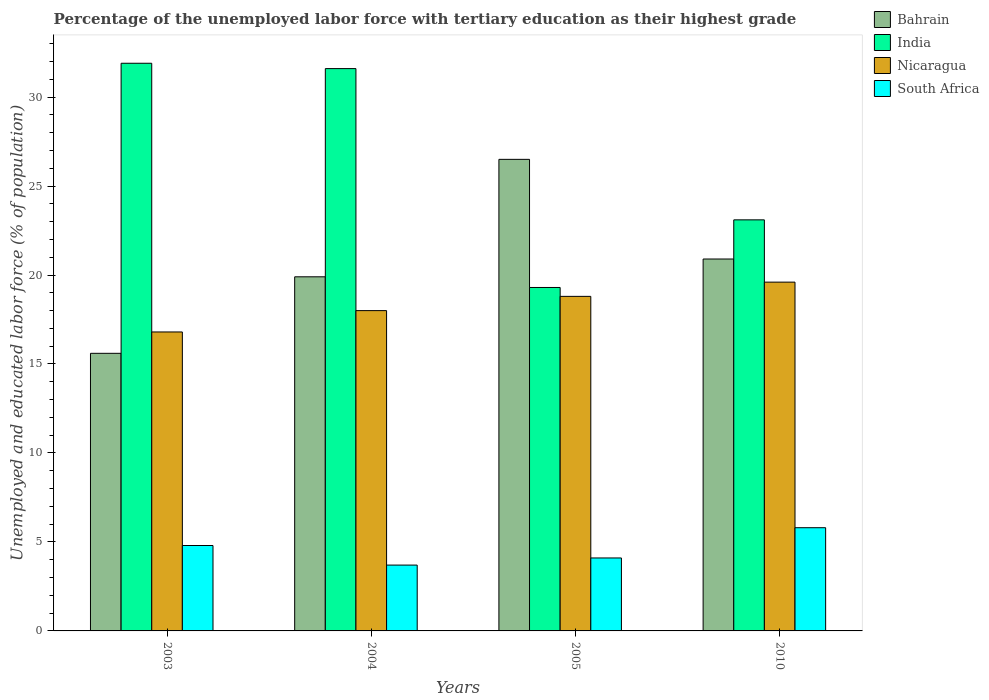Are the number of bars per tick equal to the number of legend labels?
Offer a very short reply. Yes. Are the number of bars on each tick of the X-axis equal?
Your answer should be compact. Yes. How many bars are there on the 2nd tick from the left?
Make the answer very short. 4. What is the label of the 4th group of bars from the left?
Your answer should be compact. 2010. In how many cases, is the number of bars for a given year not equal to the number of legend labels?
Your answer should be very brief. 0. What is the percentage of the unemployed labor force with tertiary education in Nicaragua in 2003?
Provide a short and direct response. 16.8. Across all years, what is the maximum percentage of the unemployed labor force with tertiary education in South Africa?
Provide a short and direct response. 5.8. Across all years, what is the minimum percentage of the unemployed labor force with tertiary education in India?
Your response must be concise. 19.3. In which year was the percentage of the unemployed labor force with tertiary education in India maximum?
Provide a short and direct response. 2003. In which year was the percentage of the unemployed labor force with tertiary education in South Africa minimum?
Your answer should be compact. 2004. What is the total percentage of the unemployed labor force with tertiary education in Bahrain in the graph?
Your response must be concise. 82.9. What is the difference between the percentage of the unemployed labor force with tertiary education in Nicaragua in 2003 and that in 2005?
Provide a succinct answer. -2. What is the difference between the percentage of the unemployed labor force with tertiary education in India in 2003 and the percentage of the unemployed labor force with tertiary education in South Africa in 2004?
Offer a terse response. 28.2. What is the average percentage of the unemployed labor force with tertiary education in India per year?
Offer a very short reply. 26.47. In the year 2003, what is the difference between the percentage of the unemployed labor force with tertiary education in Bahrain and percentage of the unemployed labor force with tertiary education in Nicaragua?
Give a very brief answer. -1.2. In how many years, is the percentage of the unemployed labor force with tertiary education in Nicaragua greater than 31 %?
Provide a short and direct response. 0. What is the ratio of the percentage of the unemployed labor force with tertiary education in Bahrain in 2005 to that in 2010?
Offer a terse response. 1.27. Is the difference between the percentage of the unemployed labor force with tertiary education in Bahrain in 2003 and 2005 greater than the difference between the percentage of the unemployed labor force with tertiary education in Nicaragua in 2003 and 2005?
Keep it short and to the point. No. What is the difference between the highest and the second highest percentage of the unemployed labor force with tertiary education in Nicaragua?
Provide a short and direct response. 0.8. What is the difference between the highest and the lowest percentage of the unemployed labor force with tertiary education in South Africa?
Offer a very short reply. 2.1. What does the 4th bar from the left in 2005 represents?
Your answer should be compact. South Africa. What does the 4th bar from the right in 2004 represents?
Your answer should be compact. Bahrain. Are all the bars in the graph horizontal?
Ensure brevity in your answer.  No. How many years are there in the graph?
Keep it short and to the point. 4. What is the difference between two consecutive major ticks on the Y-axis?
Your answer should be very brief. 5. Does the graph contain any zero values?
Your response must be concise. No. Does the graph contain grids?
Keep it short and to the point. No. How many legend labels are there?
Offer a terse response. 4. What is the title of the graph?
Make the answer very short. Percentage of the unemployed labor force with tertiary education as their highest grade. Does "Guinea-Bissau" appear as one of the legend labels in the graph?
Provide a short and direct response. No. What is the label or title of the Y-axis?
Your answer should be compact. Unemployed and educated labor force (% of population). What is the Unemployed and educated labor force (% of population) of Bahrain in 2003?
Provide a succinct answer. 15.6. What is the Unemployed and educated labor force (% of population) of India in 2003?
Keep it short and to the point. 31.9. What is the Unemployed and educated labor force (% of population) of Nicaragua in 2003?
Provide a short and direct response. 16.8. What is the Unemployed and educated labor force (% of population) of South Africa in 2003?
Provide a short and direct response. 4.8. What is the Unemployed and educated labor force (% of population) in Bahrain in 2004?
Keep it short and to the point. 19.9. What is the Unemployed and educated labor force (% of population) in India in 2004?
Your answer should be very brief. 31.6. What is the Unemployed and educated labor force (% of population) of South Africa in 2004?
Offer a very short reply. 3.7. What is the Unemployed and educated labor force (% of population) of Bahrain in 2005?
Offer a terse response. 26.5. What is the Unemployed and educated labor force (% of population) of India in 2005?
Your answer should be very brief. 19.3. What is the Unemployed and educated labor force (% of population) of Nicaragua in 2005?
Your response must be concise. 18.8. What is the Unemployed and educated labor force (% of population) in South Africa in 2005?
Provide a succinct answer. 4.1. What is the Unemployed and educated labor force (% of population) in Bahrain in 2010?
Provide a short and direct response. 20.9. What is the Unemployed and educated labor force (% of population) of India in 2010?
Keep it short and to the point. 23.1. What is the Unemployed and educated labor force (% of population) of Nicaragua in 2010?
Keep it short and to the point. 19.6. What is the Unemployed and educated labor force (% of population) in South Africa in 2010?
Provide a succinct answer. 5.8. Across all years, what is the maximum Unemployed and educated labor force (% of population) of Bahrain?
Give a very brief answer. 26.5. Across all years, what is the maximum Unemployed and educated labor force (% of population) in India?
Offer a terse response. 31.9. Across all years, what is the maximum Unemployed and educated labor force (% of population) of Nicaragua?
Provide a short and direct response. 19.6. Across all years, what is the maximum Unemployed and educated labor force (% of population) in South Africa?
Ensure brevity in your answer.  5.8. Across all years, what is the minimum Unemployed and educated labor force (% of population) in Bahrain?
Your answer should be compact. 15.6. Across all years, what is the minimum Unemployed and educated labor force (% of population) in India?
Your answer should be very brief. 19.3. Across all years, what is the minimum Unemployed and educated labor force (% of population) in Nicaragua?
Offer a terse response. 16.8. Across all years, what is the minimum Unemployed and educated labor force (% of population) in South Africa?
Make the answer very short. 3.7. What is the total Unemployed and educated labor force (% of population) in Bahrain in the graph?
Keep it short and to the point. 82.9. What is the total Unemployed and educated labor force (% of population) of India in the graph?
Offer a terse response. 105.9. What is the total Unemployed and educated labor force (% of population) of Nicaragua in the graph?
Your response must be concise. 73.2. What is the total Unemployed and educated labor force (% of population) in South Africa in the graph?
Ensure brevity in your answer.  18.4. What is the difference between the Unemployed and educated labor force (% of population) in India in 2003 and that in 2004?
Give a very brief answer. 0.3. What is the difference between the Unemployed and educated labor force (% of population) in Nicaragua in 2003 and that in 2004?
Your response must be concise. -1.2. What is the difference between the Unemployed and educated labor force (% of population) in South Africa in 2003 and that in 2004?
Provide a short and direct response. 1.1. What is the difference between the Unemployed and educated labor force (% of population) in India in 2003 and that in 2005?
Provide a short and direct response. 12.6. What is the difference between the Unemployed and educated labor force (% of population) of South Africa in 2003 and that in 2005?
Provide a succinct answer. 0.7. What is the difference between the Unemployed and educated labor force (% of population) in Bahrain in 2003 and that in 2010?
Provide a succinct answer. -5.3. What is the difference between the Unemployed and educated labor force (% of population) of India in 2003 and that in 2010?
Ensure brevity in your answer.  8.8. What is the difference between the Unemployed and educated labor force (% of population) in South Africa in 2003 and that in 2010?
Offer a terse response. -1. What is the difference between the Unemployed and educated labor force (% of population) in India in 2004 and that in 2005?
Your answer should be compact. 12.3. What is the difference between the Unemployed and educated labor force (% of population) in Nicaragua in 2004 and that in 2005?
Give a very brief answer. -0.8. What is the difference between the Unemployed and educated labor force (% of population) of South Africa in 2004 and that in 2005?
Offer a terse response. -0.4. What is the difference between the Unemployed and educated labor force (% of population) in Nicaragua in 2004 and that in 2010?
Your answer should be very brief. -1.6. What is the difference between the Unemployed and educated labor force (% of population) of South Africa in 2005 and that in 2010?
Make the answer very short. -1.7. What is the difference between the Unemployed and educated labor force (% of population) in Bahrain in 2003 and the Unemployed and educated labor force (% of population) in India in 2004?
Offer a very short reply. -16. What is the difference between the Unemployed and educated labor force (% of population) of Bahrain in 2003 and the Unemployed and educated labor force (% of population) of Nicaragua in 2004?
Your response must be concise. -2.4. What is the difference between the Unemployed and educated labor force (% of population) in India in 2003 and the Unemployed and educated labor force (% of population) in Nicaragua in 2004?
Provide a short and direct response. 13.9. What is the difference between the Unemployed and educated labor force (% of population) in India in 2003 and the Unemployed and educated labor force (% of population) in South Africa in 2004?
Provide a short and direct response. 28.2. What is the difference between the Unemployed and educated labor force (% of population) in Nicaragua in 2003 and the Unemployed and educated labor force (% of population) in South Africa in 2004?
Provide a succinct answer. 13.1. What is the difference between the Unemployed and educated labor force (% of population) in Bahrain in 2003 and the Unemployed and educated labor force (% of population) in India in 2005?
Offer a very short reply. -3.7. What is the difference between the Unemployed and educated labor force (% of population) of Bahrain in 2003 and the Unemployed and educated labor force (% of population) of South Africa in 2005?
Offer a very short reply. 11.5. What is the difference between the Unemployed and educated labor force (% of population) of India in 2003 and the Unemployed and educated labor force (% of population) of Nicaragua in 2005?
Offer a terse response. 13.1. What is the difference between the Unemployed and educated labor force (% of population) in India in 2003 and the Unemployed and educated labor force (% of population) in South Africa in 2005?
Offer a terse response. 27.8. What is the difference between the Unemployed and educated labor force (% of population) in India in 2003 and the Unemployed and educated labor force (% of population) in Nicaragua in 2010?
Provide a succinct answer. 12.3. What is the difference between the Unemployed and educated labor force (% of population) of India in 2003 and the Unemployed and educated labor force (% of population) of South Africa in 2010?
Offer a very short reply. 26.1. What is the difference between the Unemployed and educated labor force (% of population) in Nicaragua in 2003 and the Unemployed and educated labor force (% of population) in South Africa in 2010?
Ensure brevity in your answer.  11. What is the difference between the Unemployed and educated labor force (% of population) of Bahrain in 2004 and the Unemployed and educated labor force (% of population) of Nicaragua in 2005?
Provide a short and direct response. 1.1. What is the difference between the Unemployed and educated labor force (% of population) in Nicaragua in 2004 and the Unemployed and educated labor force (% of population) in South Africa in 2005?
Offer a very short reply. 13.9. What is the difference between the Unemployed and educated labor force (% of population) in Bahrain in 2004 and the Unemployed and educated labor force (% of population) in India in 2010?
Provide a short and direct response. -3.2. What is the difference between the Unemployed and educated labor force (% of population) in Bahrain in 2004 and the Unemployed and educated labor force (% of population) in Nicaragua in 2010?
Provide a succinct answer. 0.3. What is the difference between the Unemployed and educated labor force (% of population) of India in 2004 and the Unemployed and educated labor force (% of population) of Nicaragua in 2010?
Give a very brief answer. 12. What is the difference between the Unemployed and educated labor force (% of population) in India in 2004 and the Unemployed and educated labor force (% of population) in South Africa in 2010?
Offer a very short reply. 25.8. What is the difference between the Unemployed and educated labor force (% of population) of Nicaragua in 2004 and the Unemployed and educated labor force (% of population) of South Africa in 2010?
Provide a succinct answer. 12.2. What is the difference between the Unemployed and educated labor force (% of population) in Bahrain in 2005 and the Unemployed and educated labor force (% of population) in Nicaragua in 2010?
Offer a terse response. 6.9. What is the difference between the Unemployed and educated labor force (% of population) in Bahrain in 2005 and the Unemployed and educated labor force (% of population) in South Africa in 2010?
Your answer should be very brief. 20.7. What is the difference between the Unemployed and educated labor force (% of population) in Nicaragua in 2005 and the Unemployed and educated labor force (% of population) in South Africa in 2010?
Ensure brevity in your answer.  13. What is the average Unemployed and educated labor force (% of population) in Bahrain per year?
Give a very brief answer. 20.73. What is the average Unemployed and educated labor force (% of population) of India per year?
Ensure brevity in your answer.  26.48. In the year 2003, what is the difference between the Unemployed and educated labor force (% of population) of Bahrain and Unemployed and educated labor force (% of population) of India?
Provide a succinct answer. -16.3. In the year 2003, what is the difference between the Unemployed and educated labor force (% of population) of India and Unemployed and educated labor force (% of population) of Nicaragua?
Your response must be concise. 15.1. In the year 2003, what is the difference between the Unemployed and educated labor force (% of population) in India and Unemployed and educated labor force (% of population) in South Africa?
Your answer should be very brief. 27.1. In the year 2004, what is the difference between the Unemployed and educated labor force (% of population) of India and Unemployed and educated labor force (% of population) of Nicaragua?
Offer a very short reply. 13.6. In the year 2004, what is the difference between the Unemployed and educated labor force (% of population) in India and Unemployed and educated labor force (% of population) in South Africa?
Ensure brevity in your answer.  27.9. In the year 2004, what is the difference between the Unemployed and educated labor force (% of population) of Nicaragua and Unemployed and educated labor force (% of population) of South Africa?
Keep it short and to the point. 14.3. In the year 2005, what is the difference between the Unemployed and educated labor force (% of population) in Bahrain and Unemployed and educated labor force (% of population) in India?
Offer a very short reply. 7.2. In the year 2005, what is the difference between the Unemployed and educated labor force (% of population) in Bahrain and Unemployed and educated labor force (% of population) in Nicaragua?
Make the answer very short. 7.7. In the year 2005, what is the difference between the Unemployed and educated labor force (% of population) in Bahrain and Unemployed and educated labor force (% of population) in South Africa?
Provide a short and direct response. 22.4. In the year 2005, what is the difference between the Unemployed and educated labor force (% of population) in India and Unemployed and educated labor force (% of population) in South Africa?
Ensure brevity in your answer.  15.2. In the year 2010, what is the difference between the Unemployed and educated labor force (% of population) of Bahrain and Unemployed and educated labor force (% of population) of South Africa?
Offer a very short reply. 15.1. In the year 2010, what is the difference between the Unemployed and educated labor force (% of population) in India and Unemployed and educated labor force (% of population) in Nicaragua?
Offer a terse response. 3.5. What is the ratio of the Unemployed and educated labor force (% of population) in Bahrain in 2003 to that in 2004?
Offer a very short reply. 0.78. What is the ratio of the Unemployed and educated labor force (% of population) of India in 2003 to that in 2004?
Offer a terse response. 1.01. What is the ratio of the Unemployed and educated labor force (% of population) in Nicaragua in 2003 to that in 2004?
Keep it short and to the point. 0.93. What is the ratio of the Unemployed and educated labor force (% of population) of South Africa in 2003 to that in 2004?
Provide a succinct answer. 1.3. What is the ratio of the Unemployed and educated labor force (% of population) of Bahrain in 2003 to that in 2005?
Keep it short and to the point. 0.59. What is the ratio of the Unemployed and educated labor force (% of population) of India in 2003 to that in 2005?
Give a very brief answer. 1.65. What is the ratio of the Unemployed and educated labor force (% of population) in Nicaragua in 2003 to that in 2005?
Give a very brief answer. 0.89. What is the ratio of the Unemployed and educated labor force (% of population) in South Africa in 2003 to that in 2005?
Offer a very short reply. 1.17. What is the ratio of the Unemployed and educated labor force (% of population) in Bahrain in 2003 to that in 2010?
Offer a terse response. 0.75. What is the ratio of the Unemployed and educated labor force (% of population) of India in 2003 to that in 2010?
Ensure brevity in your answer.  1.38. What is the ratio of the Unemployed and educated labor force (% of population) of Nicaragua in 2003 to that in 2010?
Offer a terse response. 0.86. What is the ratio of the Unemployed and educated labor force (% of population) of South Africa in 2003 to that in 2010?
Provide a short and direct response. 0.83. What is the ratio of the Unemployed and educated labor force (% of population) of Bahrain in 2004 to that in 2005?
Your answer should be very brief. 0.75. What is the ratio of the Unemployed and educated labor force (% of population) in India in 2004 to that in 2005?
Provide a short and direct response. 1.64. What is the ratio of the Unemployed and educated labor force (% of population) in Nicaragua in 2004 to that in 2005?
Keep it short and to the point. 0.96. What is the ratio of the Unemployed and educated labor force (% of population) of South Africa in 2004 to that in 2005?
Provide a succinct answer. 0.9. What is the ratio of the Unemployed and educated labor force (% of population) of Bahrain in 2004 to that in 2010?
Your answer should be very brief. 0.95. What is the ratio of the Unemployed and educated labor force (% of population) of India in 2004 to that in 2010?
Your answer should be very brief. 1.37. What is the ratio of the Unemployed and educated labor force (% of population) in Nicaragua in 2004 to that in 2010?
Your answer should be very brief. 0.92. What is the ratio of the Unemployed and educated labor force (% of population) in South Africa in 2004 to that in 2010?
Your response must be concise. 0.64. What is the ratio of the Unemployed and educated labor force (% of population) in Bahrain in 2005 to that in 2010?
Keep it short and to the point. 1.27. What is the ratio of the Unemployed and educated labor force (% of population) of India in 2005 to that in 2010?
Make the answer very short. 0.84. What is the ratio of the Unemployed and educated labor force (% of population) in Nicaragua in 2005 to that in 2010?
Give a very brief answer. 0.96. What is the ratio of the Unemployed and educated labor force (% of population) of South Africa in 2005 to that in 2010?
Provide a short and direct response. 0.71. What is the difference between the highest and the second highest Unemployed and educated labor force (% of population) of Nicaragua?
Offer a very short reply. 0.8. What is the difference between the highest and the second highest Unemployed and educated labor force (% of population) of South Africa?
Offer a very short reply. 1. 